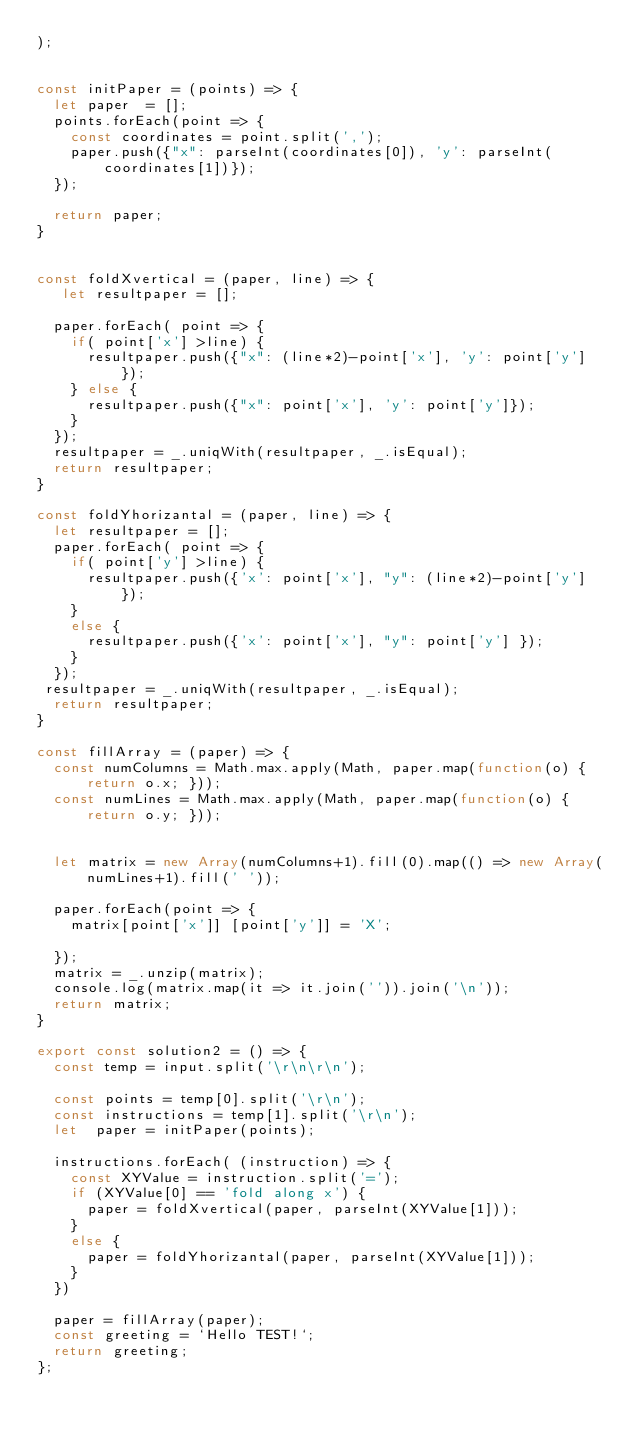Convert code to text. <code><loc_0><loc_0><loc_500><loc_500><_TypeScript_>);


const initPaper = (points) => {
  let paper  = [];
  points.forEach(point => {
    const coordinates = point.split(',');
    paper.push({"x": parseInt(coordinates[0]), 'y': parseInt(coordinates[1])});
  });

  return paper;
}


const foldXvertical = (paper, line) => {
   let resultpaper = [];

  paper.forEach( point => {
    if( point['x'] >line) {
      resultpaper.push({"x": (line*2)-point['x'], 'y': point['y'] });
    } else {
      resultpaper.push({"x": point['x'], 'y': point['y']});
    }
  });
  resultpaper = _.uniqWith(resultpaper, _.isEqual);
  return resultpaper;
}

const foldYhorizantal = (paper, line) => {
  let resultpaper = [];
  paper.forEach( point => {
    if( point['y'] >line) {
      resultpaper.push({'x': point['x'], "y": (line*2)-point['y'] });
    }
    else {
      resultpaper.push({'x': point['x'], "y": point['y'] });
    }
  });
 resultpaper = _.uniqWith(resultpaper, _.isEqual);
  return resultpaper;
}

const fillArray = (paper) => {
  const numColumns = Math.max.apply(Math, paper.map(function(o) { return o.x; }));
  const numLines = Math.max.apply(Math, paper.map(function(o) { return o.y; }));


  let matrix = new Array(numColumns+1).fill(0).map(() => new Array(numLines+1).fill(' '));

  paper.forEach(point => {
    matrix[point['x']] [point['y']] = 'X';
    
  });
  matrix = _.unzip(matrix);
  console.log(matrix.map(it => it.join('')).join('\n'));
  return matrix;
}

export const solution2 = () => {
  const temp = input.split('\r\n\r\n');

  const points = temp[0].split('\r\n');
  const instructions = temp[1].split('\r\n');
  let  paper = initPaper(points);

  instructions.forEach( (instruction) => {
    const XYValue = instruction.split('=');
    if (XYValue[0] == 'fold along x') {
      paper = foldXvertical(paper, parseInt(XYValue[1]));
    }
    else {
      paper = foldYhorizantal(paper, parseInt(XYValue[1]));
    }
  })

  paper = fillArray(paper);
  const greeting = `Hello TEST!`;
  return greeting;
};
</code> 